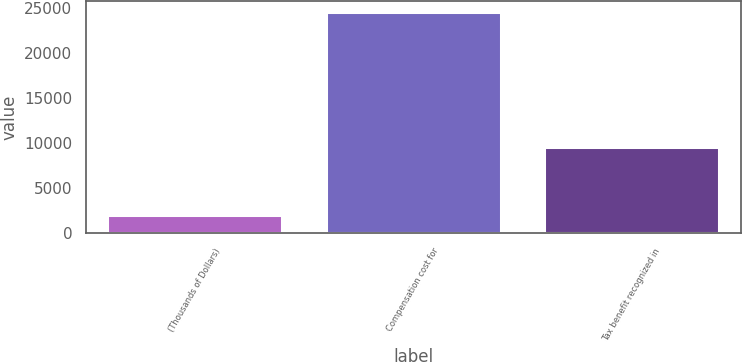Convert chart to OTSL. <chart><loc_0><loc_0><loc_500><loc_500><bar_chart><fcel>(Thousands of Dollars)<fcel>Compensation cost for<fcel>Tax benefit recognized in<nl><fcel>2013<fcel>24613<fcel>9571<nl></chart> 